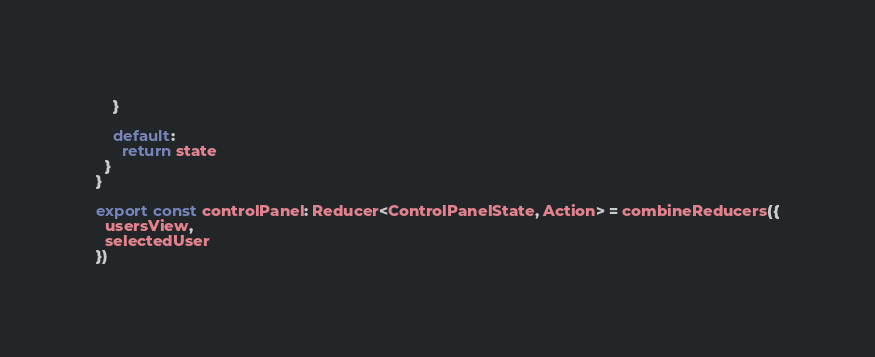Convert code to text. <code><loc_0><loc_0><loc_500><loc_500><_JavaScript_>    }

    default:
      return state
  }
}

export const controlPanel: Reducer<ControlPanelState, Action> = combineReducers({
  usersView,
  selectedUser
})
</code> 